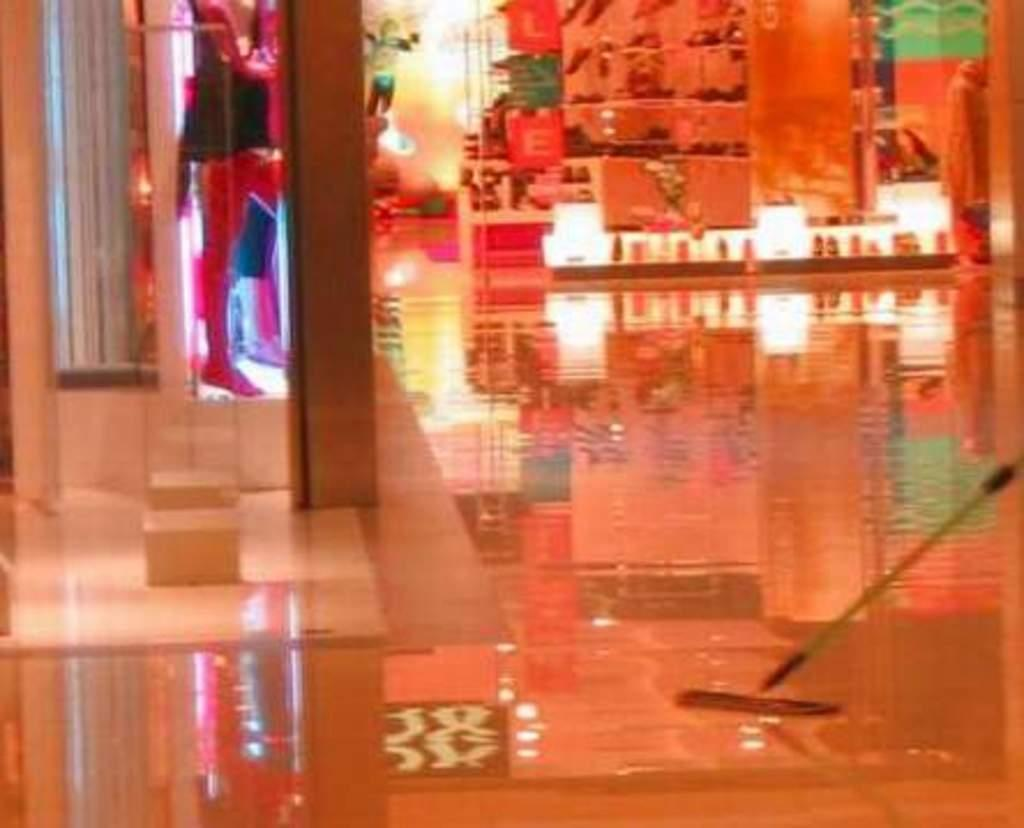What type of surface is visible at the bottom of the image? There is a floor visible in the image. What type of establishments can be seen in the image? There are shops in the image. What does the committee discuss in the image? There is no committee present in the image, so it is not possible to determine what they might discuss. 